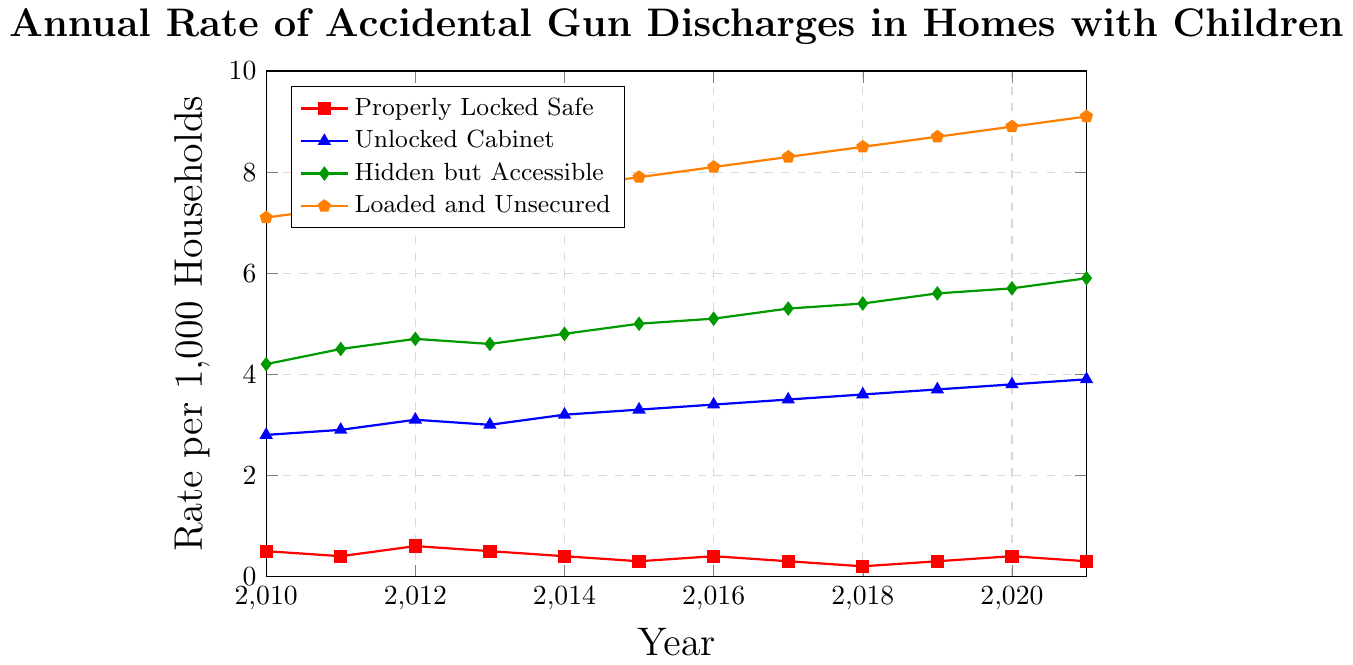In 2015, how much higher was the rate of accidental discharges for 'Loaded and Unsecured' compared to 'Hidden but Accessible'? The rate for 'Loaded and Unsecured' in 2015 is 7.9, and for 'Hidden but Accessible' it is 5.0. The difference is 7.9 - 5.0 = 2.9.
Answer: 2.9 What is the combined rate of accidental discharges for all firearm storage methods in 2021? Adding the rates for all methods in 2021: 0.3 (Properly Locked Safe) + 3.9 (Unlocked Cabinet) + 5.9 (Hidden but Accessible) + 9.1 (Loaded and Unsecured) = 19.2.
Answer: 19.2 How does the rate of accidental discharges for 'Properly Locked Safe' in 2018 compare to 2010? In 2018, the rate for 'Properly Locked Safe' is 0.2, and in 2010 it is 0.5. 0.2 is 0.3 lower than 0.5.
Answer: 0.3 lower Is the rate of accidental discharges for 'Hidden but Accessible' always higher than 'Unlocked Cabinet' from 2010 to 2021? By comparing the rates for 'Hidden but Accessible' and 'Unlocked Cabinet' for each year from 2010 to 2021, 'Hidden but Accessible' consistently has higher rates than 'Unlocked Cabinet' each year.
Answer: Yes In which year was the rate of accidental discharges for 'Properly Locked Safe' the lowest, and what was the rate? The lowest rate for 'Properly Locked Safe' occurred in 2018, with a rate of 0.2.
Answer: 2018, 0.2 What is the average rate of accidental discharges for 'Hidden but Accessible' over the 12 years? Adding the rates from 2010 to 2021 for 'Hidden but Accessible' and dividing by 12: (4.2 + 4.5 + 4.7 + 4.6 + 4.8 + 5.0 + 5.1 + 5.3 + 5.4 + 5.6 + 5.7 + 5.9)/12 = 5.04.
Answer: 5.04 